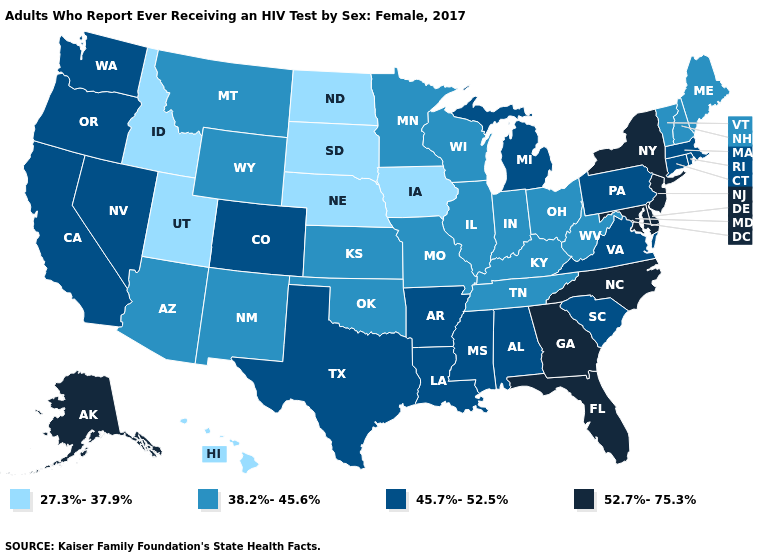Among the states that border Massachusetts , which have the lowest value?
Write a very short answer. New Hampshire, Vermont. Does Washington have a lower value than Montana?
Concise answer only. No. How many symbols are there in the legend?
Write a very short answer. 4. Does Montana have a lower value than Utah?
Write a very short answer. No. Which states hav the highest value in the West?
Write a very short answer. Alaska. What is the value of Pennsylvania?
Quick response, please. 45.7%-52.5%. Among the states that border Pennsylvania , does Ohio have the highest value?
Keep it brief. No. What is the lowest value in the USA?
Write a very short answer. 27.3%-37.9%. Is the legend a continuous bar?
Answer briefly. No. Name the states that have a value in the range 38.2%-45.6%?
Answer briefly. Arizona, Illinois, Indiana, Kansas, Kentucky, Maine, Minnesota, Missouri, Montana, New Hampshire, New Mexico, Ohio, Oklahoma, Tennessee, Vermont, West Virginia, Wisconsin, Wyoming. What is the value of Rhode Island?
Answer briefly. 45.7%-52.5%. Name the states that have a value in the range 38.2%-45.6%?
Give a very brief answer. Arizona, Illinois, Indiana, Kansas, Kentucky, Maine, Minnesota, Missouri, Montana, New Hampshire, New Mexico, Ohio, Oklahoma, Tennessee, Vermont, West Virginia, Wisconsin, Wyoming. Which states have the lowest value in the USA?
Keep it brief. Hawaii, Idaho, Iowa, Nebraska, North Dakota, South Dakota, Utah. What is the lowest value in states that border Arizona?
Give a very brief answer. 27.3%-37.9%. What is the lowest value in states that border Missouri?
Answer briefly. 27.3%-37.9%. 